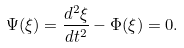Convert formula to latex. <formula><loc_0><loc_0><loc_500><loc_500>\Psi ( \xi ) = \frac { d ^ { 2 } \xi } { d t ^ { 2 } } - \Phi ( \xi ) = 0 .</formula> 